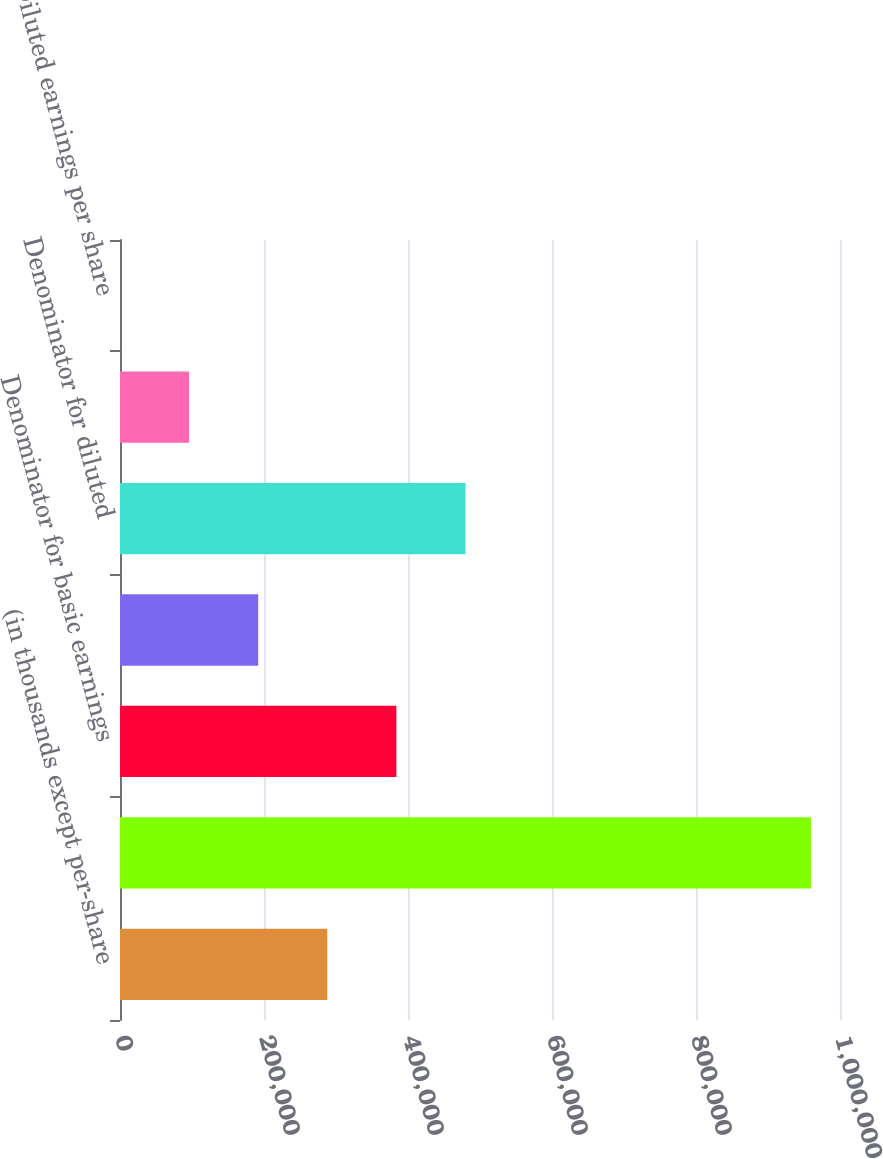<chart> <loc_0><loc_0><loc_500><loc_500><bar_chart><fcel>(in thousands except per-share<fcel>Net income used in computing<fcel>Denominator for basic earnings<fcel>Effect of dilutive securities<fcel>Denominator for diluted<fcel>Basic earnings per share<fcel>Diluted earnings per share<nl><fcel>287884<fcel>959604<fcel>383844<fcel>191924<fcel>479804<fcel>95963.5<fcel>3.41<nl></chart> 